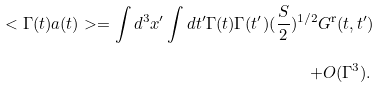<formula> <loc_0><loc_0><loc_500><loc_500>< \Gamma ( t ) a ( t ) > = \int d ^ { 3 } x ^ { \prime } \int d t ^ { \prime } \Gamma ( t ) \Gamma ( t ^ { \prime } ) ( \frac { S } { 2 } ) ^ { 1 / 2 } G ^ { \text {r} } ( t , t ^ { \prime } ) \\ \quad \ + O ( \Gamma ^ { 3 } ) . \,</formula> 